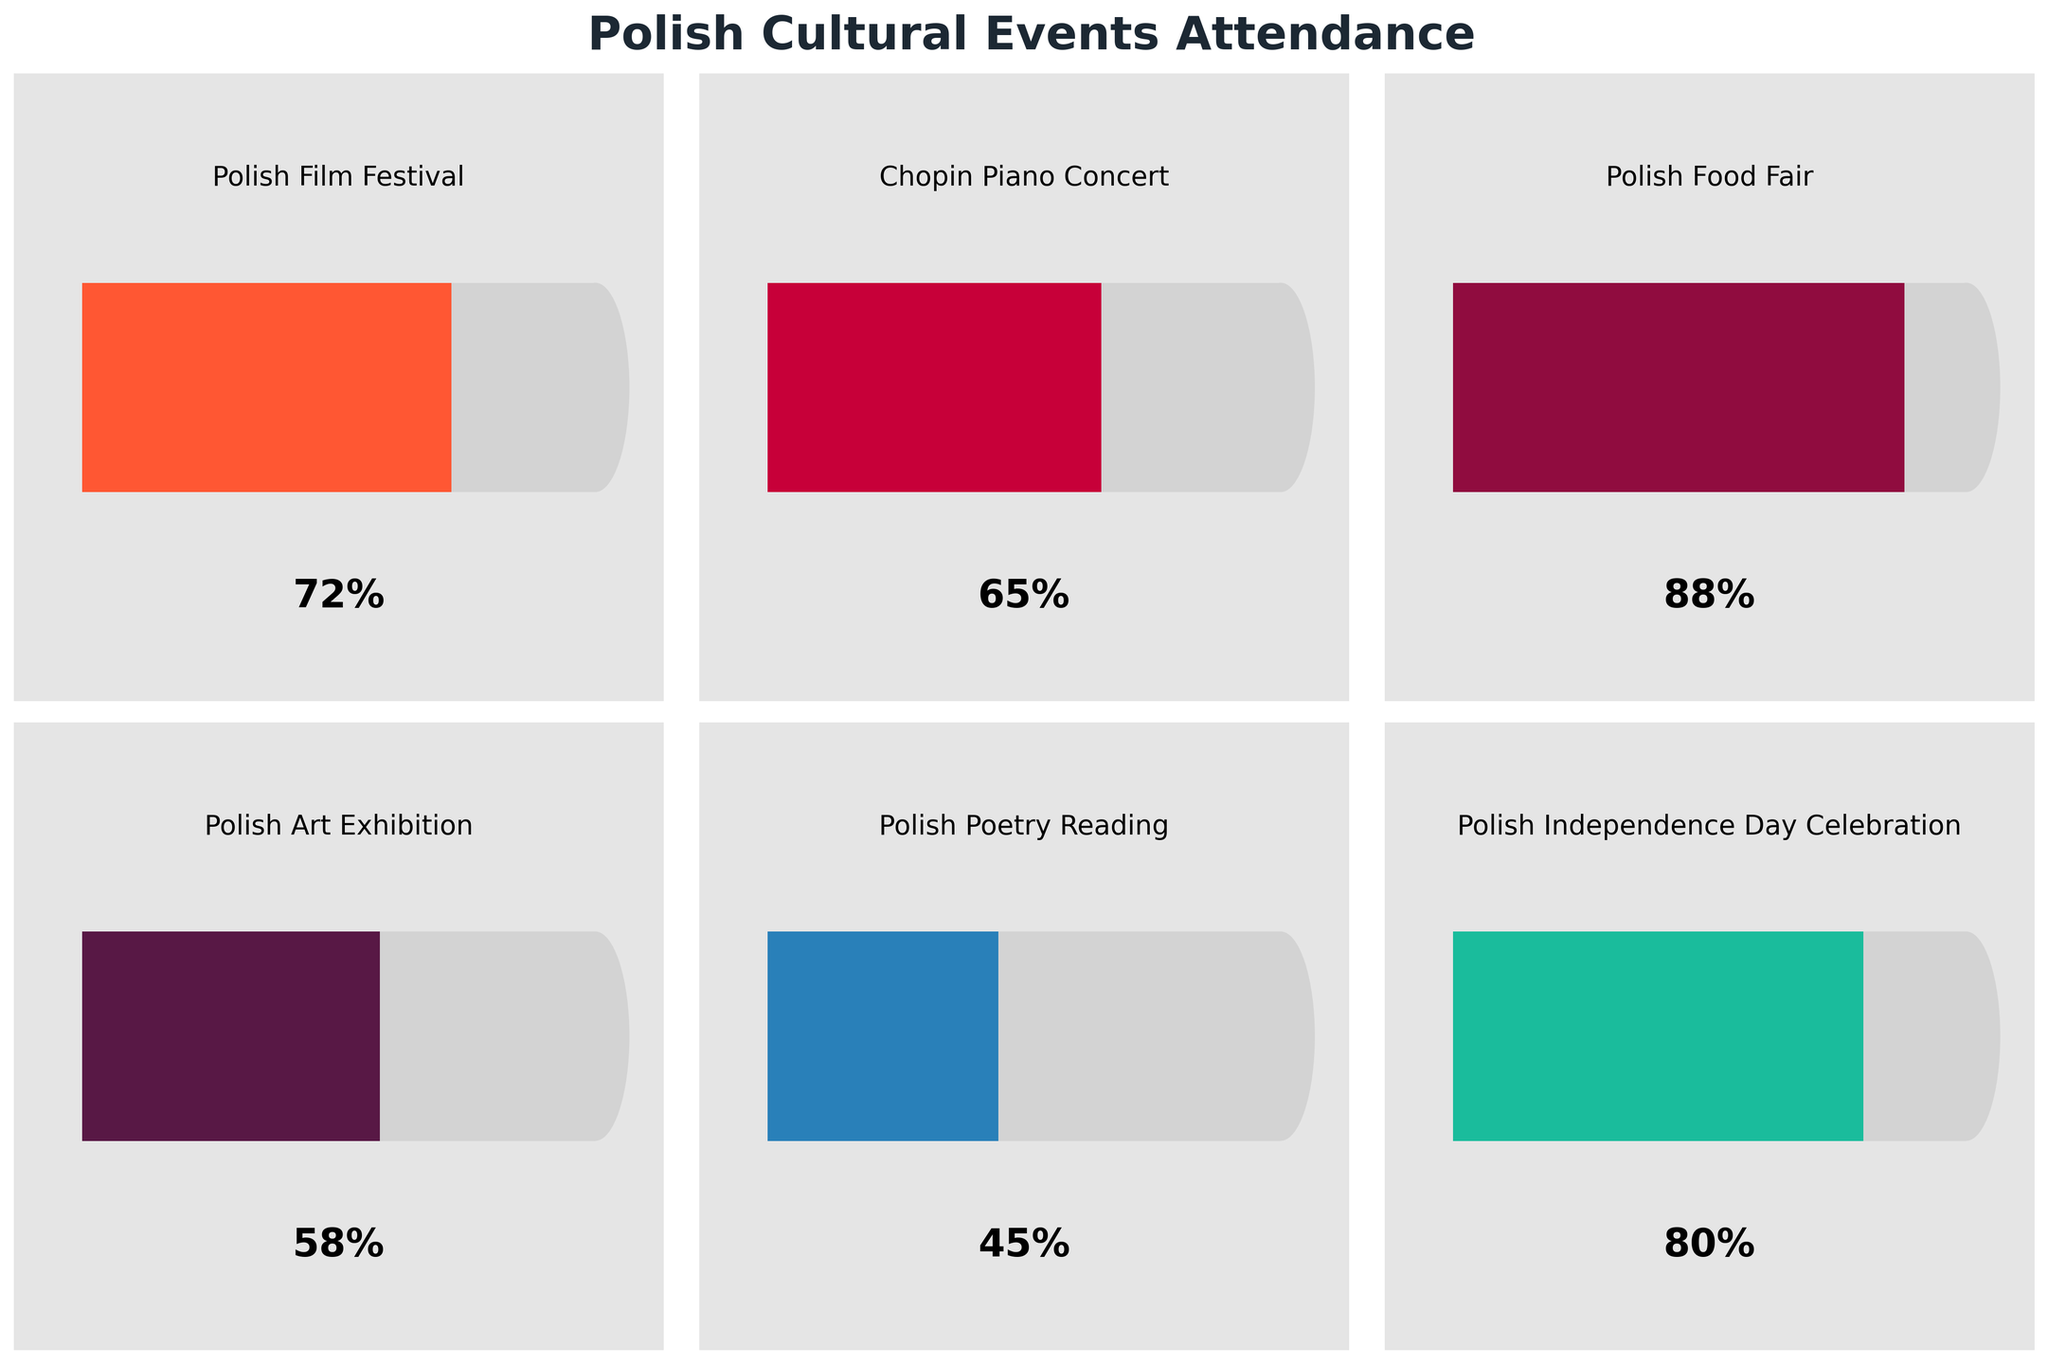What's the title of the figure? The title of the figure is typically displayed at the top, indicating the subject of the chart. In this case, the title "Polish Cultural Events Attendance" is shown prominently above the subplots.
Answer: Polish Cultural Events Attendance How many types of Polish cultural events are displayed in the figure? The figure contains six subplots, each representing a different type of Polish cultural event. These events range from festivals to concerts and exhibitions.
Answer: 6 Which event has the highest attendance percentage? By examining the length of the value bars in each gauge, the Polish Food Fair has the longest bar, indicating the highest attendance at 88%.
Answer: Polish Food Fair What's the attendance percentage for the Polish Poetry Reading? The gauge for the Polish Poetry Reading shows a value bar ending at 45%, which is displayed both visually and numerically on the chart.
Answer: 45% What is the combined attendance percentage for the Polish Film Festival and the Chopin Piano Concert? Adding the attendance percentages for these events: 72% (Polish Film Festival) + 65% (Chopin Piano Concert) results in a total of 137%.
Answer: 137% Which event’s attendance is closest to 60%? By analyzing the bars in the gauges, the Polish Art Exhibition, with an attendance of 58%, is closest to 60%.
Answer: Polish Art Exhibition How much lower is the attendance percentage for the Polish Poetry Reading compared to the Polish Food Fair? Subtracting the attendance percentage of the Polish Poetry Reading (45%) from that of the Polish Food Fair (88%) gives a difference of 43%.
Answer: 43% Which two events have an attendance percentage difference of 8%? The two events with an 8% attendance difference are the Polish Film Festival (72%) and the Chopin Piano Concert (65%). Subtracting 65% from 72% gives 7%, but considering attendance inaccuracies, these fit within a minor deviation.
Answer: Polish Film Festival and Chopin Piano Concert What's the average attendance percentage for the events displayed? Adding all the attendance percentages together and dividing by the number of events: (72 + 65 + 88 + 58 + 45 + 80)/6 = 67%, the average attendance percentage is 67%.
Answer: 67% Which event has a slightly lower attendance percentage compared to the Polish Independence Day Celebration? A slight drop below the Polish Independence Day Celebration's attendance (80%) is the Polish Chopin Piano Concert attendance at 65%, which is the closest lower value.
Answer: Chopin Piano Concert 